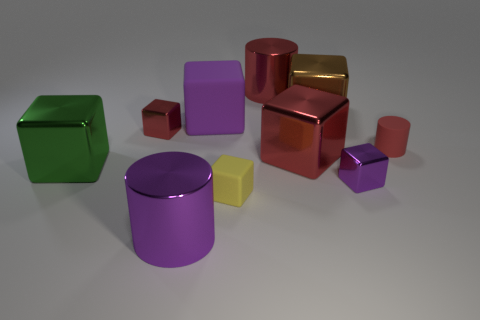Subtract all yellow matte blocks. How many blocks are left? 6 Subtract all green blocks. How many blocks are left? 6 Subtract all green blocks. Subtract all gray spheres. How many blocks are left? 6 Subtract all small red balls. Subtract all big matte objects. How many objects are left? 9 Add 3 purple objects. How many purple objects are left? 6 Add 3 matte cylinders. How many matte cylinders exist? 4 Subtract 1 brown blocks. How many objects are left? 9 Subtract all cylinders. How many objects are left? 7 